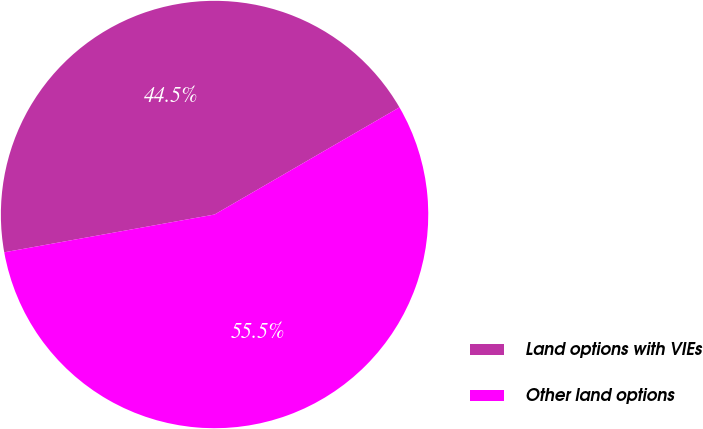Convert chart. <chart><loc_0><loc_0><loc_500><loc_500><pie_chart><fcel>Land options with VIEs<fcel>Other land options<nl><fcel>44.47%<fcel>55.53%<nl></chart> 